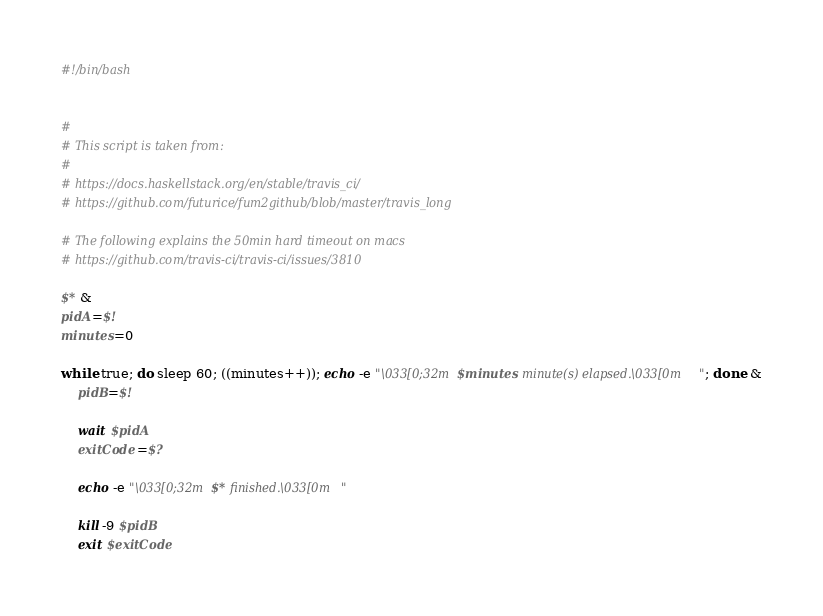<code> <loc_0><loc_0><loc_500><loc_500><_Bash_>#!/bin/bash


# 
# This script is taken from:
# 
# https://docs.haskellstack.org/en/stable/travis_ci/
# https://github.com/futurice/fum2github/blob/master/travis_long

# The following explains the 50min hard timeout on macs
# https://github.com/travis-ci/travis-ci/issues/3810

$* &
pidA=$!
minutes=0

while true; do sleep 60; ((minutes++)); echo -e "\033[0;32m$minutes minute(s) elapsed.\033[0m"; done &
    pidB=$!

    wait $pidA
    exitCode=$?

    echo -e "\033[0;32m$* finished.\033[0m"

    kill -9 $pidB
    exit $exitCode
</code> 